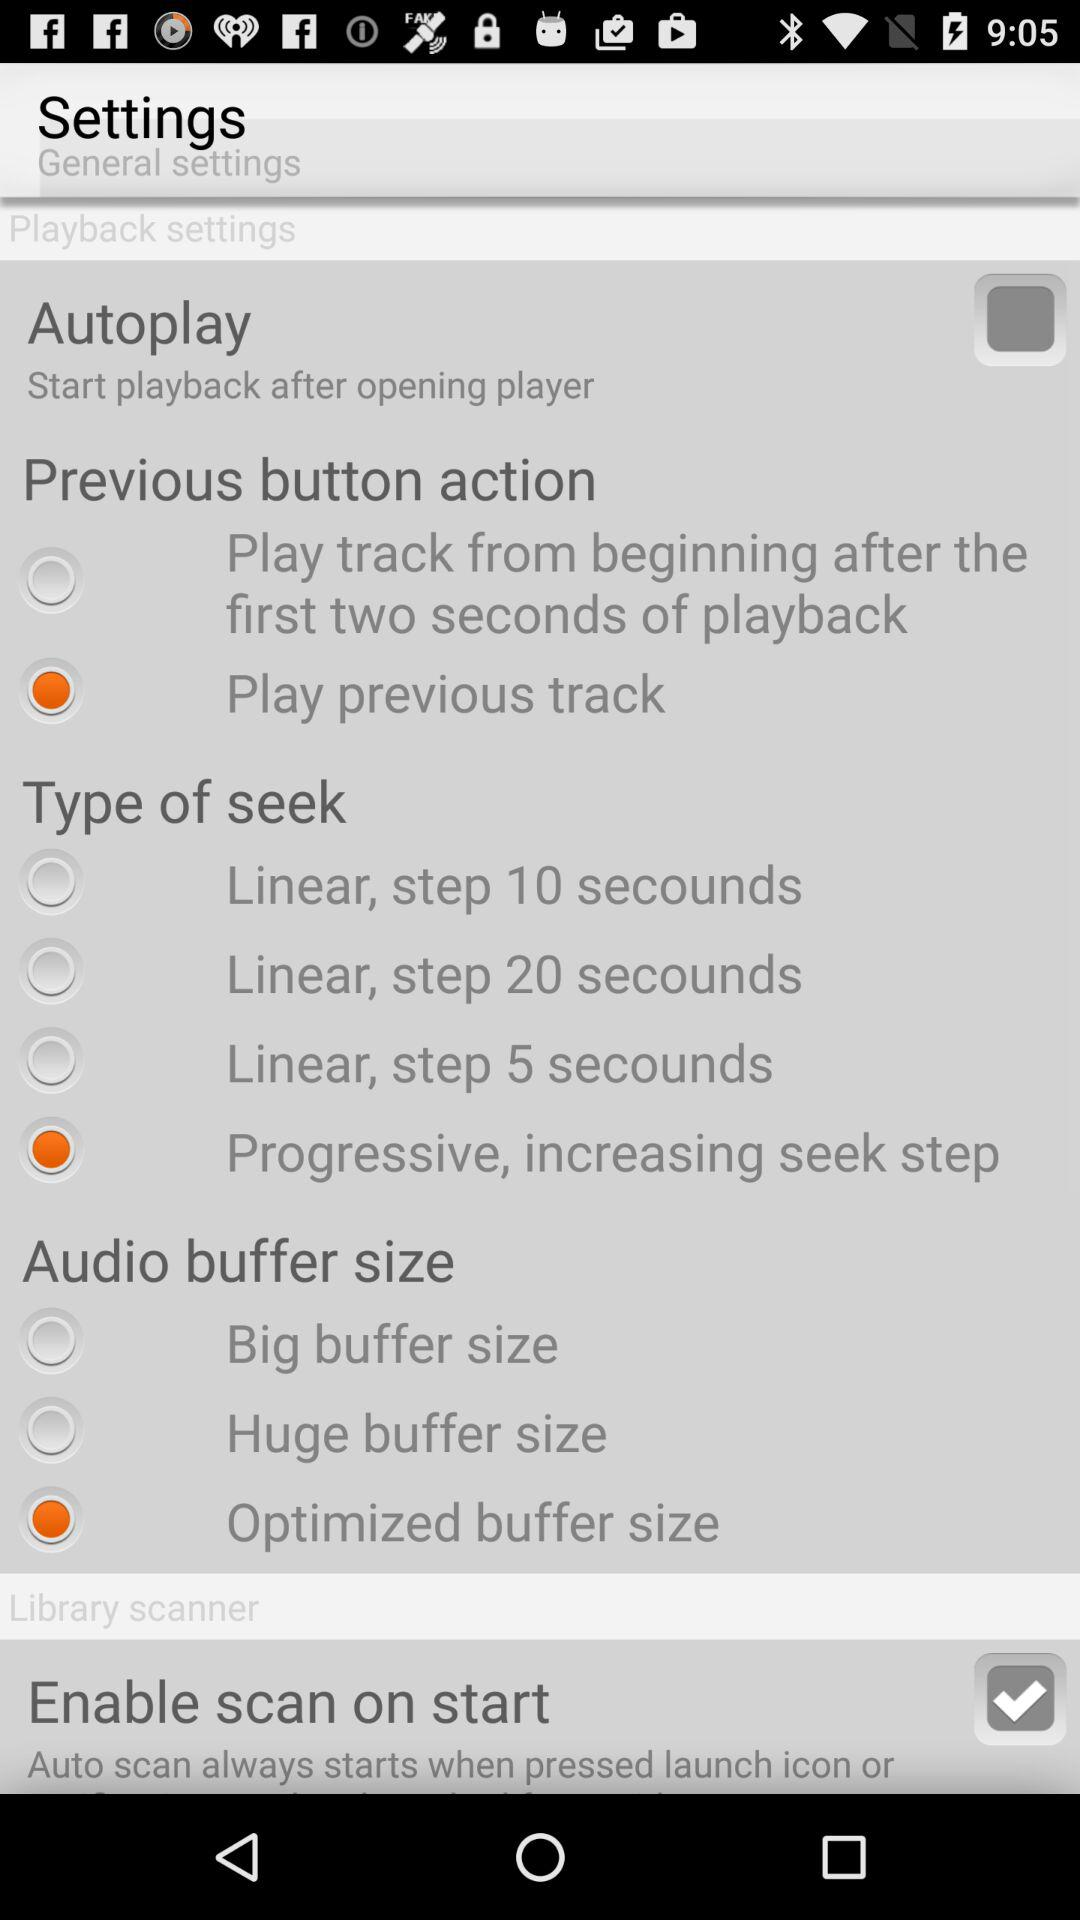What is the status of "Enable scan on start"? The status is "on". 